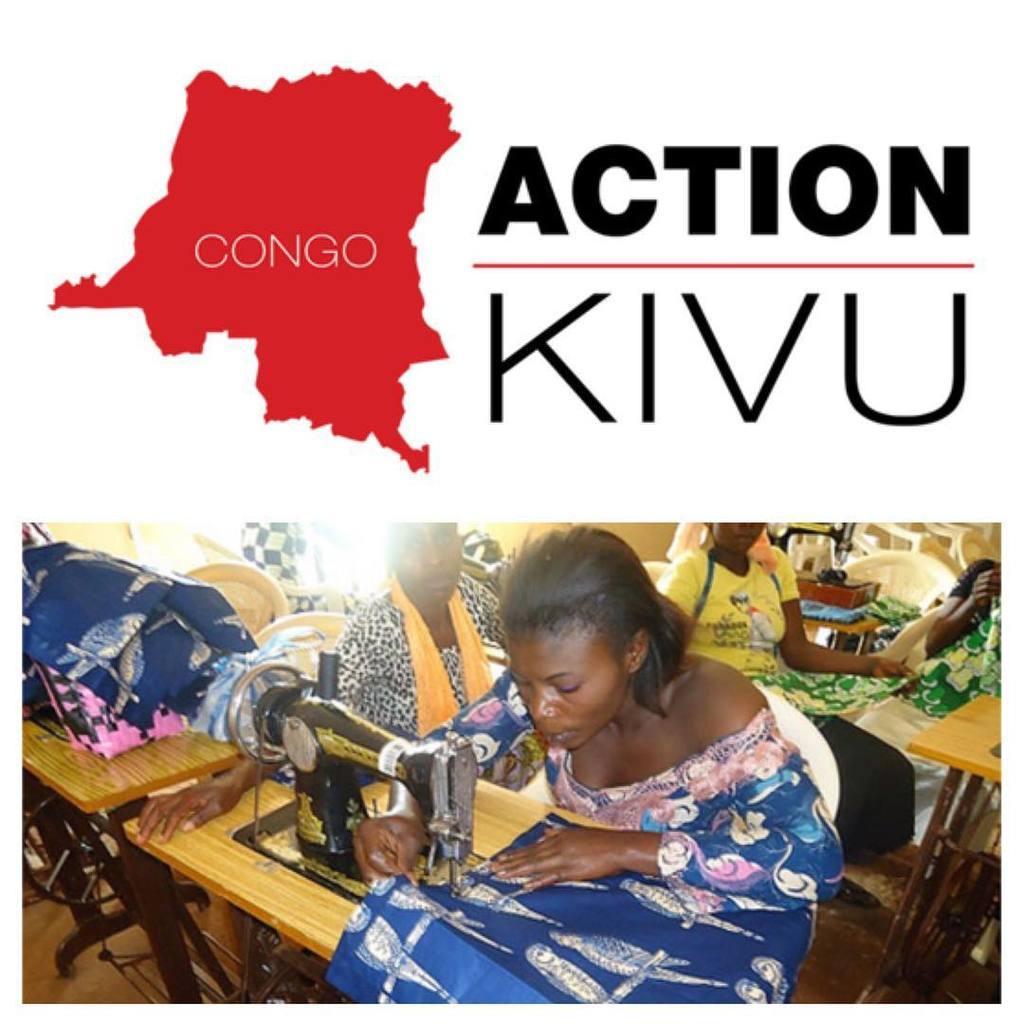Can you describe this image briefly? In this image I can see women are sitting on chairs. I can also see some machines on wooden tables. In the background I can see chairs. Here I can see a logo. 